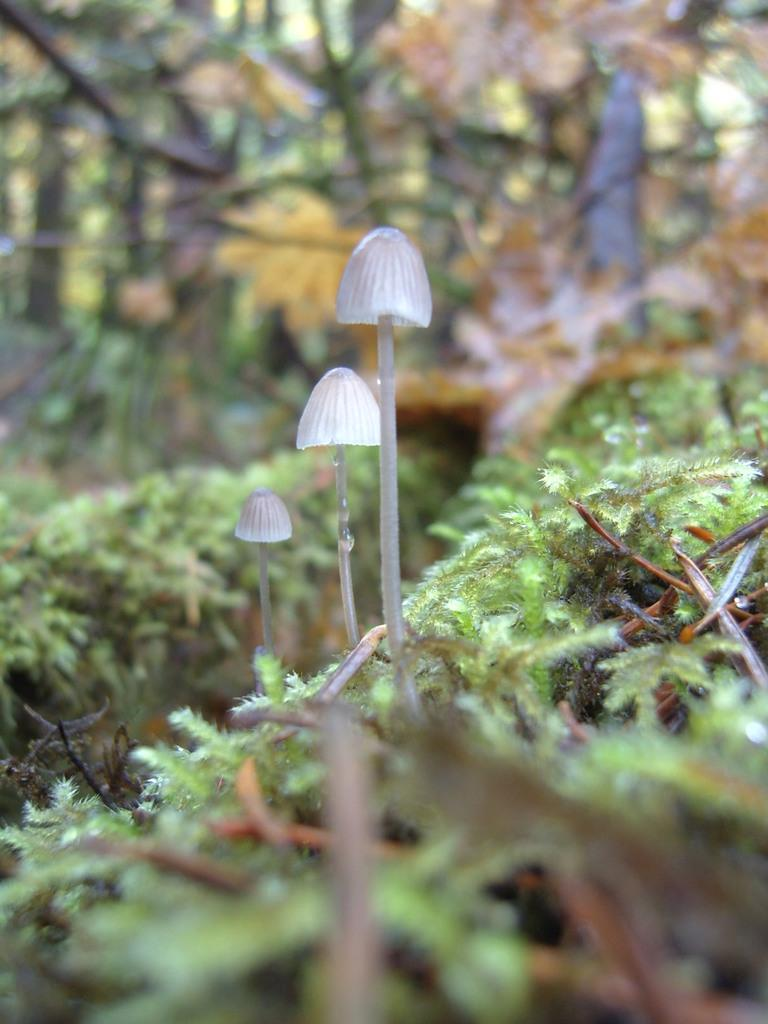What color are the trees in the image? The trees in the image are green in color. What grade does the crib in the image have? There is no crib present in the image, so it is not possible to determine its grade. 